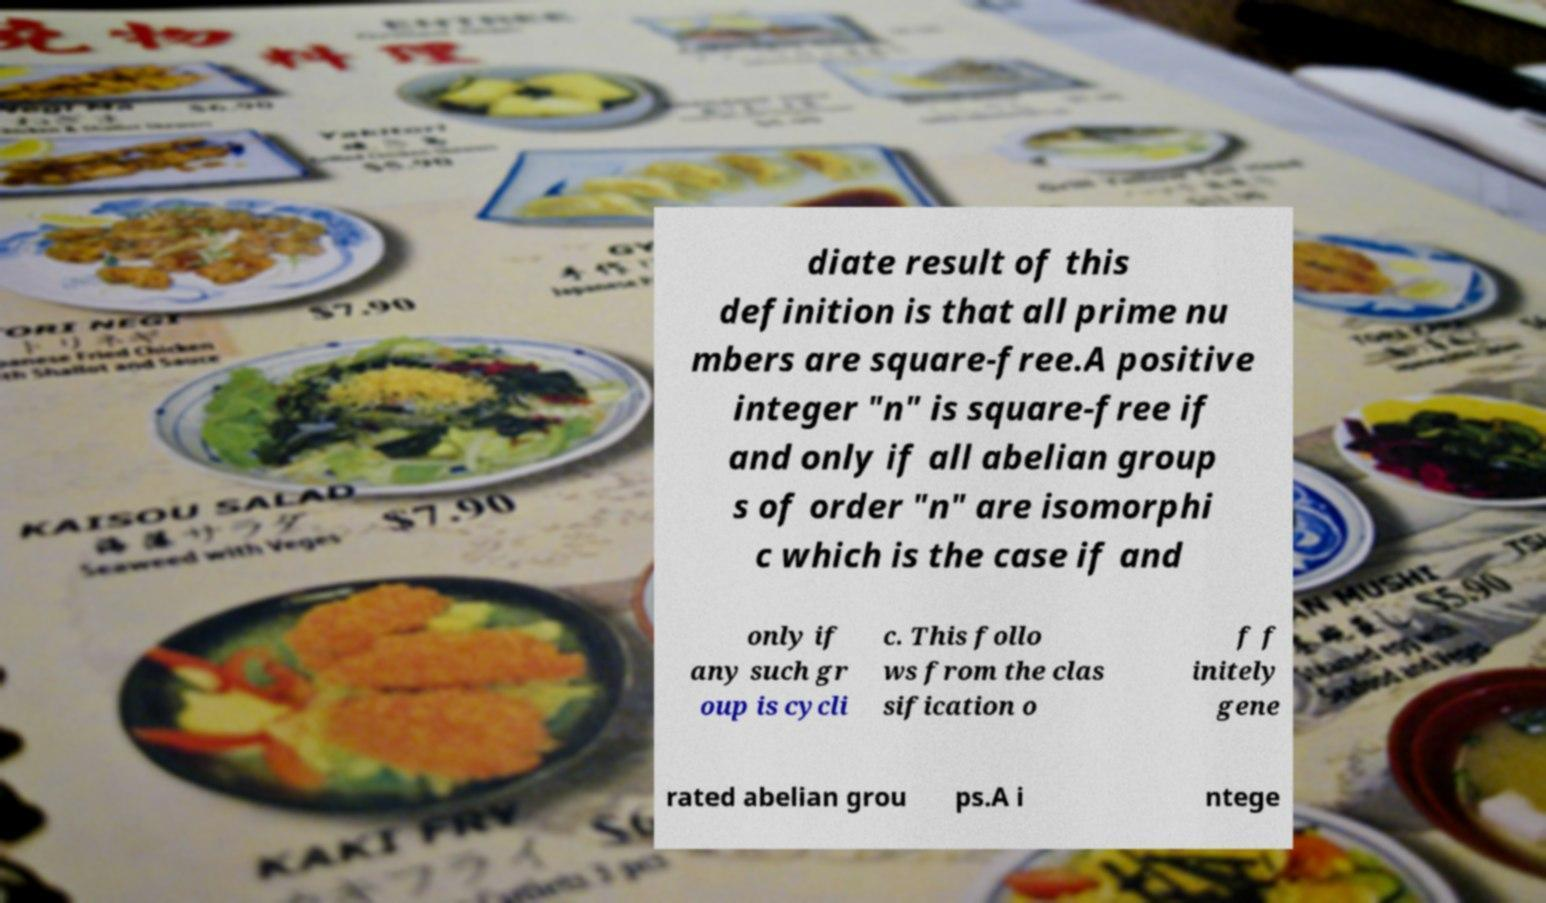I need the written content from this picture converted into text. Can you do that? diate result of this definition is that all prime nu mbers are square-free.A positive integer "n" is square-free if and only if all abelian group s of order "n" are isomorphi c which is the case if and only if any such gr oup is cycli c. This follo ws from the clas sification o f f initely gene rated abelian grou ps.A i ntege 